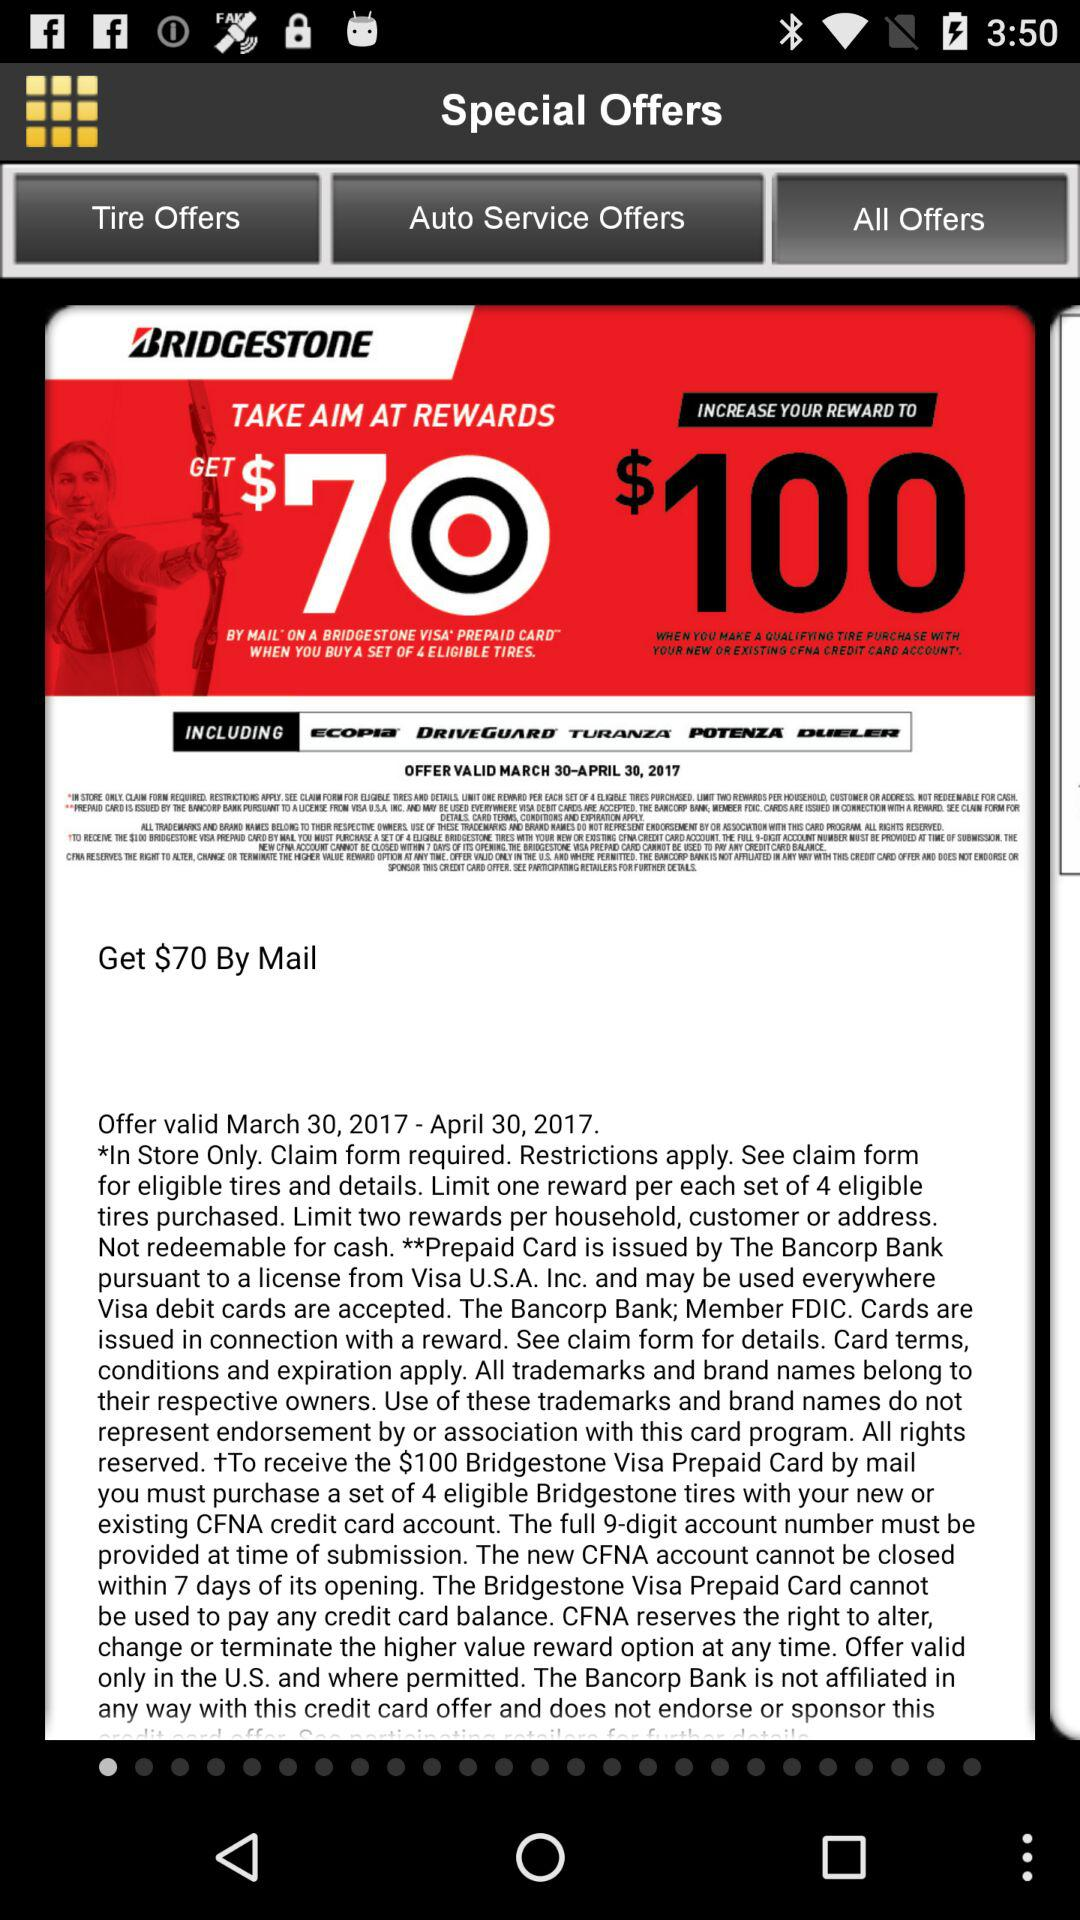What is the valid date of the offer? The offer is valid from March 30, 2017 to April 30, 2017. 